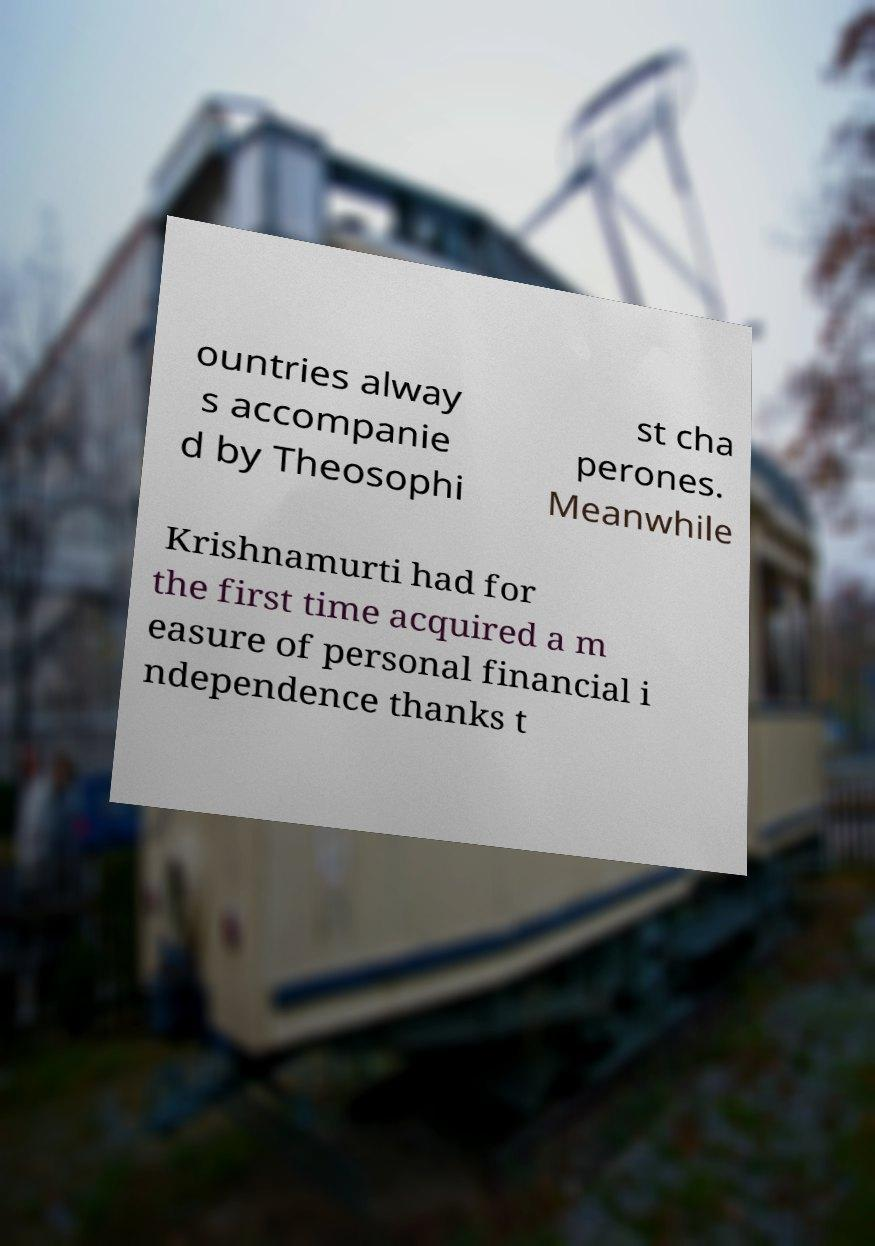What messages or text are displayed in this image? I need them in a readable, typed format. ountries alway s accompanie d by Theosophi st cha perones. Meanwhile Krishnamurti had for the first time acquired a m easure of personal financial i ndependence thanks t 